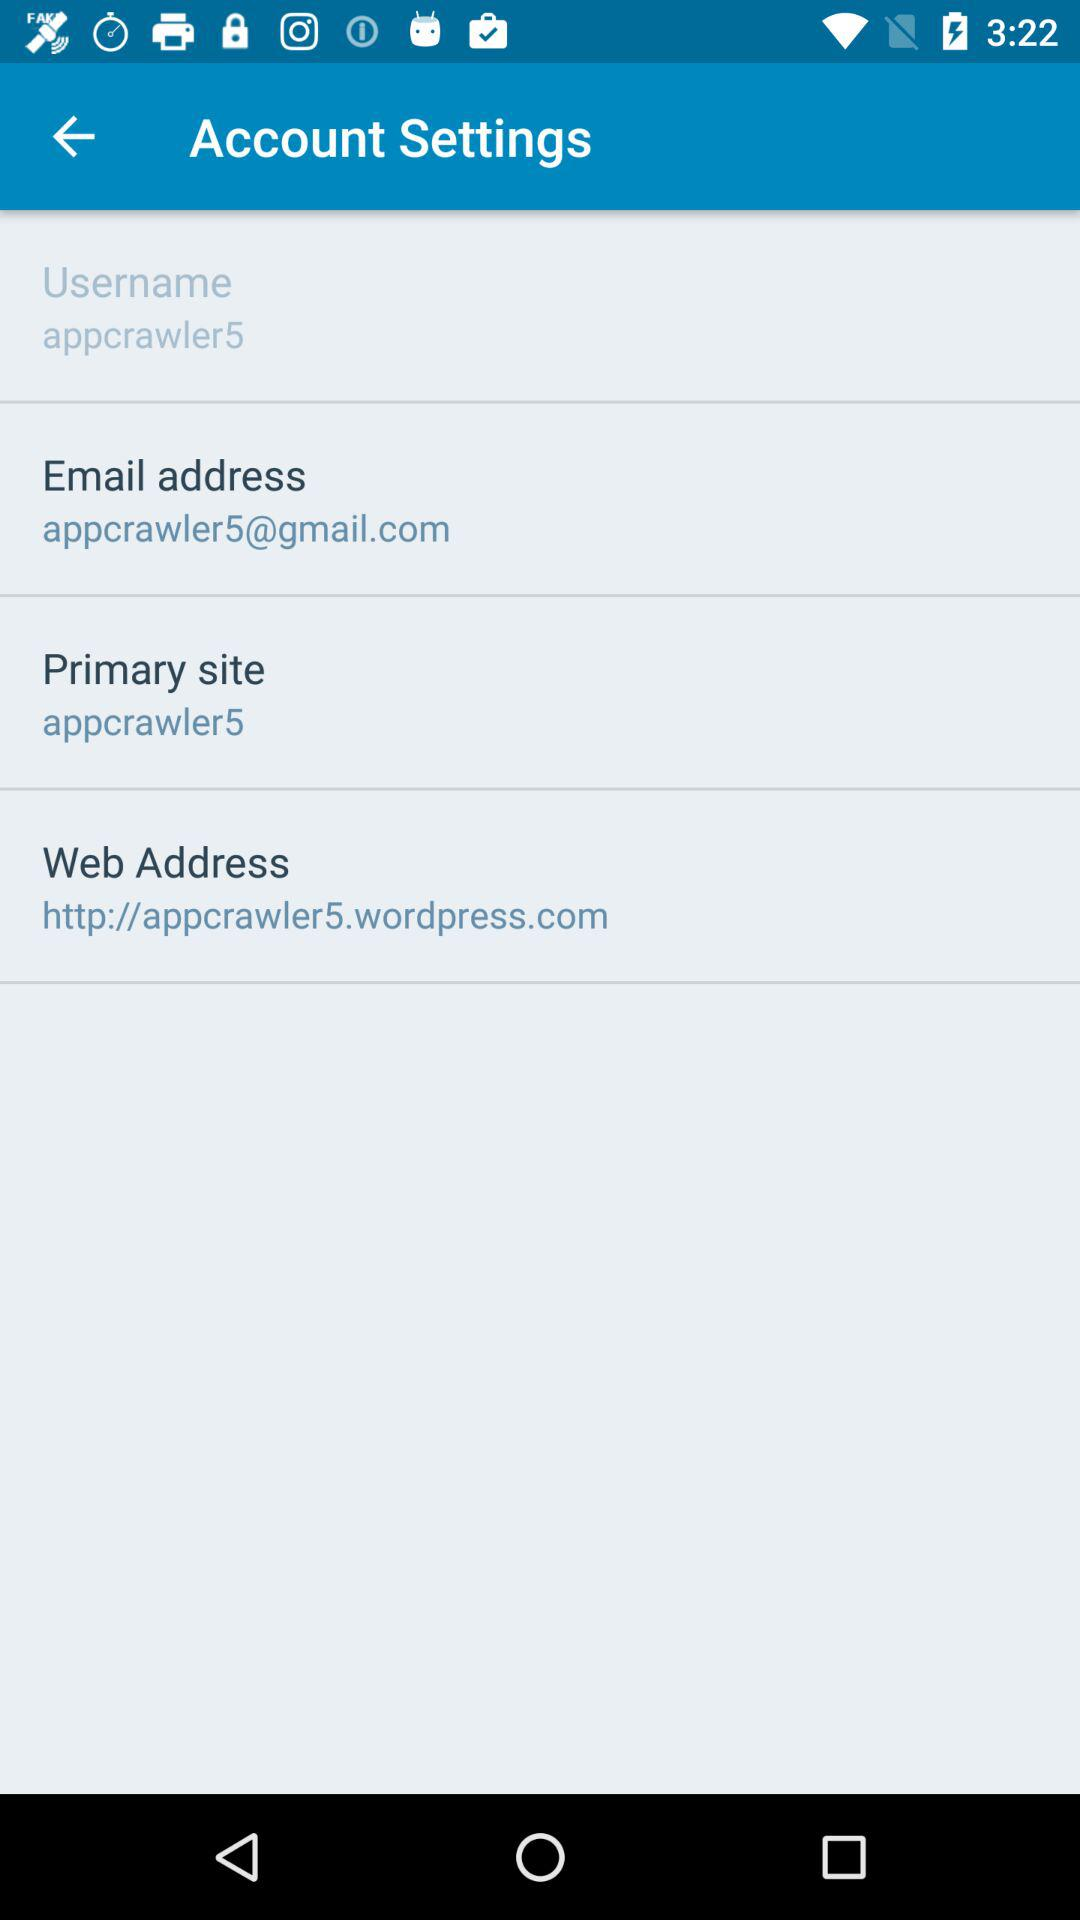What is the Gmail address used by the user? The Gmail address used by the user is appcrawler5@gmail.com. 